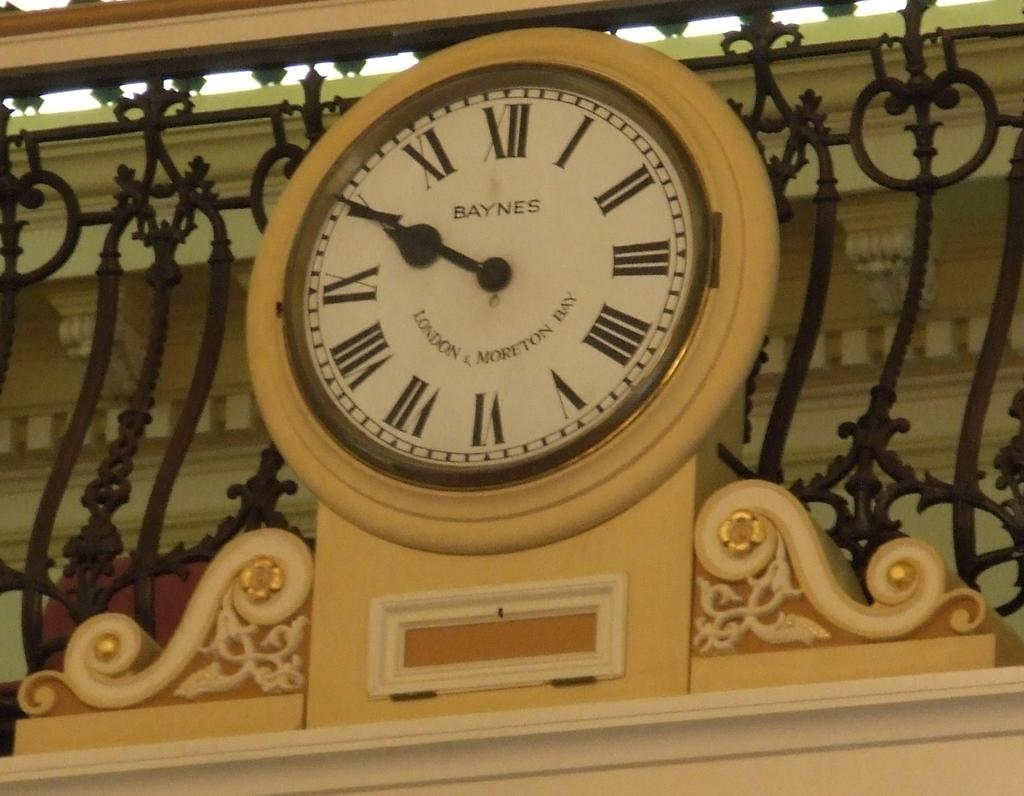<image>
Give a short and clear explanation of the subsequent image. A decorative Baynes clock states the time as ten minutes till ten. 